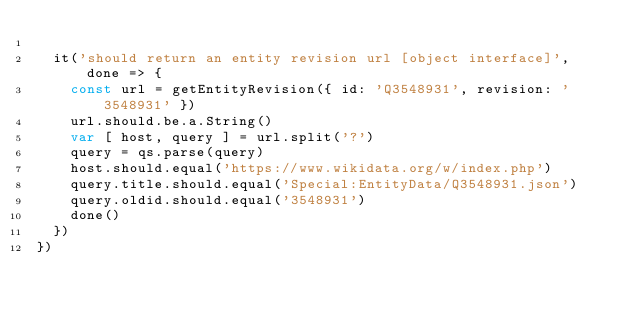<code> <loc_0><loc_0><loc_500><loc_500><_JavaScript_>
  it('should return an entity revision url [object interface]', done => {
    const url = getEntityRevision({ id: 'Q3548931', revision: '3548931' })
    url.should.be.a.String()
    var [ host, query ] = url.split('?')
    query = qs.parse(query)
    host.should.equal('https://www.wikidata.org/w/index.php')
    query.title.should.equal('Special:EntityData/Q3548931.json')
    query.oldid.should.equal('3548931')
    done()
  })
})
</code> 